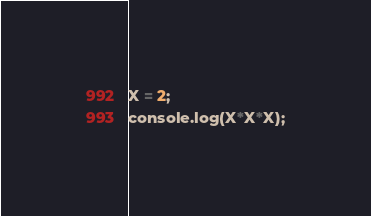Convert code to text. <code><loc_0><loc_0><loc_500><loc_500><_JavaScript_>X = 2;
console.log(X*X*X);</code> 